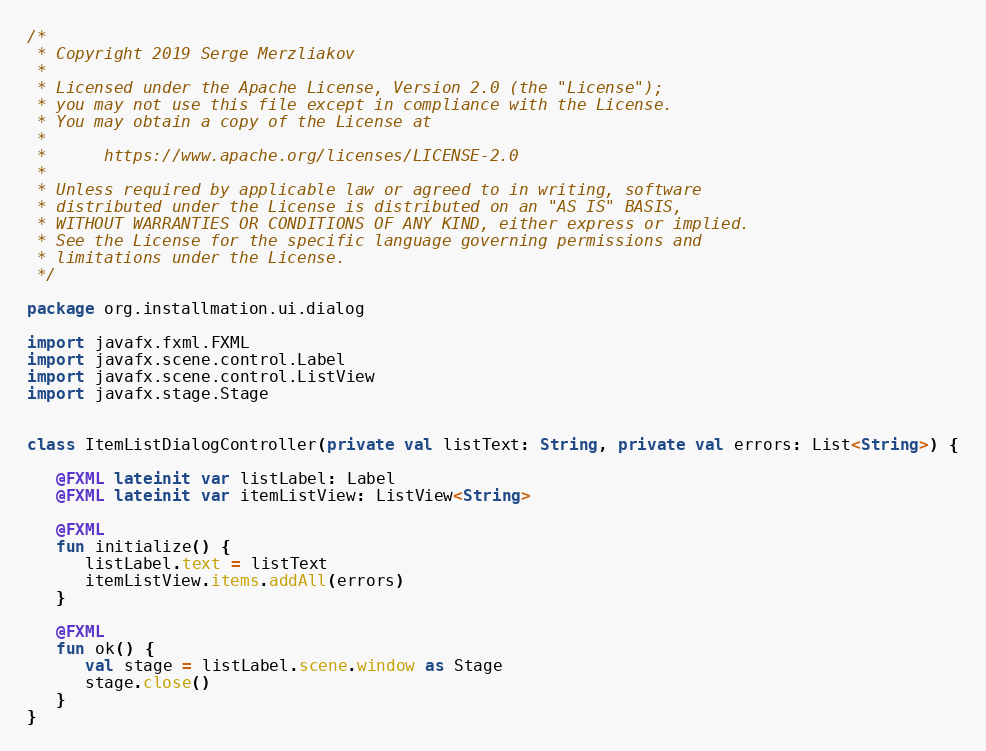<code> <loc_0><loc_0><loc_500><loc_500><_Kotlin_>/*
 * Copyright 2019 Serge Merzliakov
 *
 * Licensed under the Apache License, Version 2.0 (the "License");
 * you may not use this file except in compliance with the License.
 * You may obtain a copy of the License at
 *
 *      https://www.apache.org/licenses/LICENSE-2.0
 *
 * Unless required by applicable law or agreed to in writing, software
 * distributed under the License is distributed on an "AS IS" BASIS,
 * WITHOUT WARRANTIES OR CONDITIONS OF ANY KIND, either express or implied.
 * See the License for the specific language governing permissions and
 * limitations under the License.
 */

package org.installmation.ui.dialog

import javafx.fxml.FXML
import javafx.scene.control.Label
import javafx.scene.control.ListView
import javafx.stage.Stage


class ItemListDialogController(private val listText: String, private val errors: List<String>) {

   @FXML lateinit var listLabel: Label
   @FXML lateinit var itemListView: ListView<String>

   @FXML
   fun initialize() {
      listLabel.text = listText
      itemListView.items.addAll(errors)
   }

   @FXML
   fun ok() {
      val stage = listLabel.scene.window as Stage
      stage.close()
   }
}</code> 